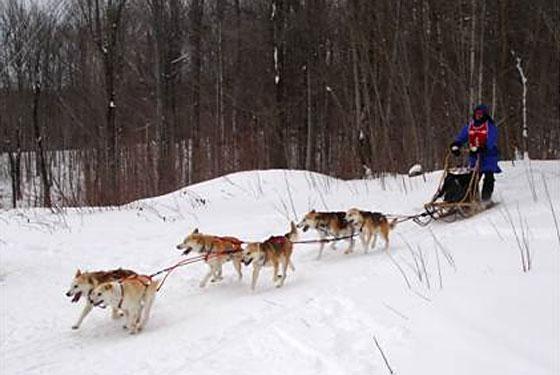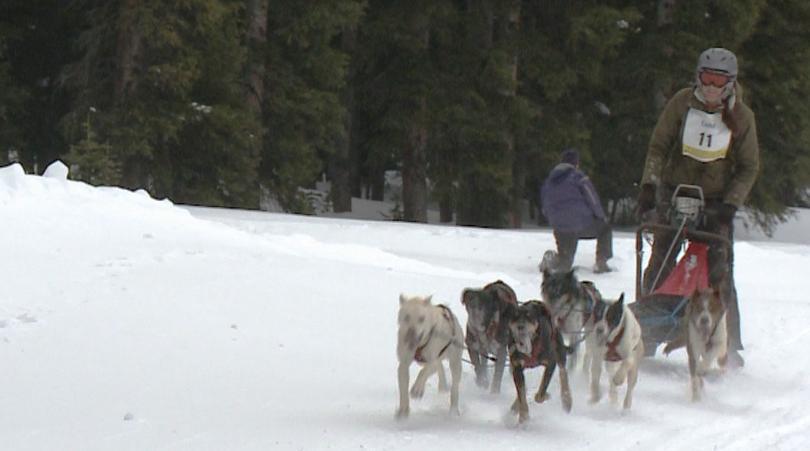The first image is the image on the left, the second image is the image on the right. Considering the images on both sides, is "An image shows a sled driver standing behind an empty sled, and only two visible dogs pulling it." valid? Answer yes or no. No. 